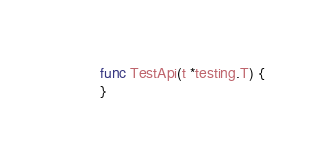<code> <loc_0><loc_0><loc_500><loc_500><_Go_>
func TestApi(t *testing.T) {
}
</code> 